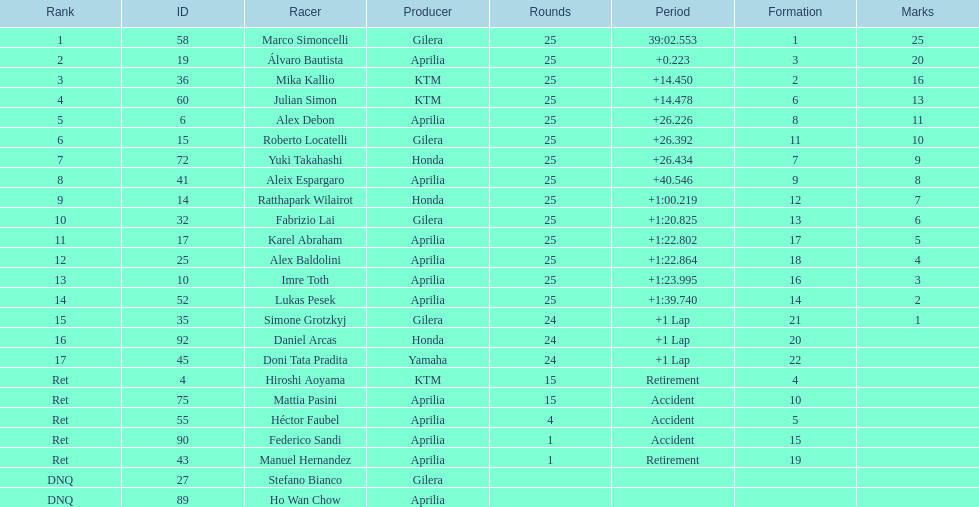Did marco simoncelli or alvaro bautista held rank 1? Marco Simoncelli. Parse the table in full. {'header': ['Rank', 'ID', 'Racer', 'Producer', 'Rounds', 'Period', 'Formation', 'Marks'], 'rows': [['1', '58', 'Marco Simoncelli', 'Gilera', '25', '39:02.553', '1', '25'], ['2', '19', 'Álvaro Bautista', 'Aprilia', '25', '+0.223', '3', '20'], ['3', '36', 'Mika Kallio', 'KTM', '25', '+14.450', '2', '16'], ['4', '60', 'Julian Simon', 'KTM', '25', '+14.478', '6', '13'], ['5', '6', 'Alex Debon', 'Aprilia', '25', '+26.226', '8', '11'], ['6', '15', 'Roberto Locatelli', 'Gilera', '25', '+26.392', '11', '10'], ['7', '72', 'Yuki Takahashi', 'Honda', '25', '+26.434', '7', '9'], ['8', '41', 'Aleix Espargaro', 'Aprilia', '25', '+40.546', '9', '8'], ['9', '14', 'Ratthapark Wilairot', 'Honda', '25', '+1:00.219', '12', '7'], ['10', '32', 'Fabrizio Lai', 'Gilera', '25', '+1:20.825', '13', '6'], ['11', '17', 'Karel Abraham', 'Aprilia', '25', '+1:22.802', '17', '5'], ['12', '25', 'Alex Baldolini', 'Aprilia', '25', '+1:22.864', '18', '4'], ['13', '10', 'Imre Toth', 'Aprilia', '25', '+1:23.995', '16', '3'], ['14', '52', 'Lukas Pesek', 'Aprilia', '25', '+1:39.740', '14', '2'], ['15', '35', 'Simone Grotzkyj', 'Gilera', '24', '+1 Lap', '21', '1'], ['16', '92', 'Daniel Arcas', 'Honda', '24', '+1 Lap', '20', ''], ['17', '45', 'Doni Tata Pradita', 'Yamaha', '24', '+1 Lap', '22', ''], ['Ret', '4', 'Hiroshi Aoyama', 'KTM', '15', 'Retirement', '4', ''], ['Ret', '75', 'Mattia Pasini', 'Aprilia', '15', 'Accident', '10', ''], ['Ret', '55', 'Héctor Faubel', 'Aprilia', '4', 'Accident', '5', ''], ['Ret', '90', 'Federico Sandi', 'Aprilia', '1', 'Accident', '15', ''], ['Ret', '43', 'Manuel Hernandez', 'Aprilia', '1', 'Retirement', '19', ''], ['DNQ', '27', 'Stefano Bianco', 'Gilera', '', '', '', ''], ['DNQ', '89', 'Ho Wan Chow', 'Aprilia', '', '', '', '']]} 